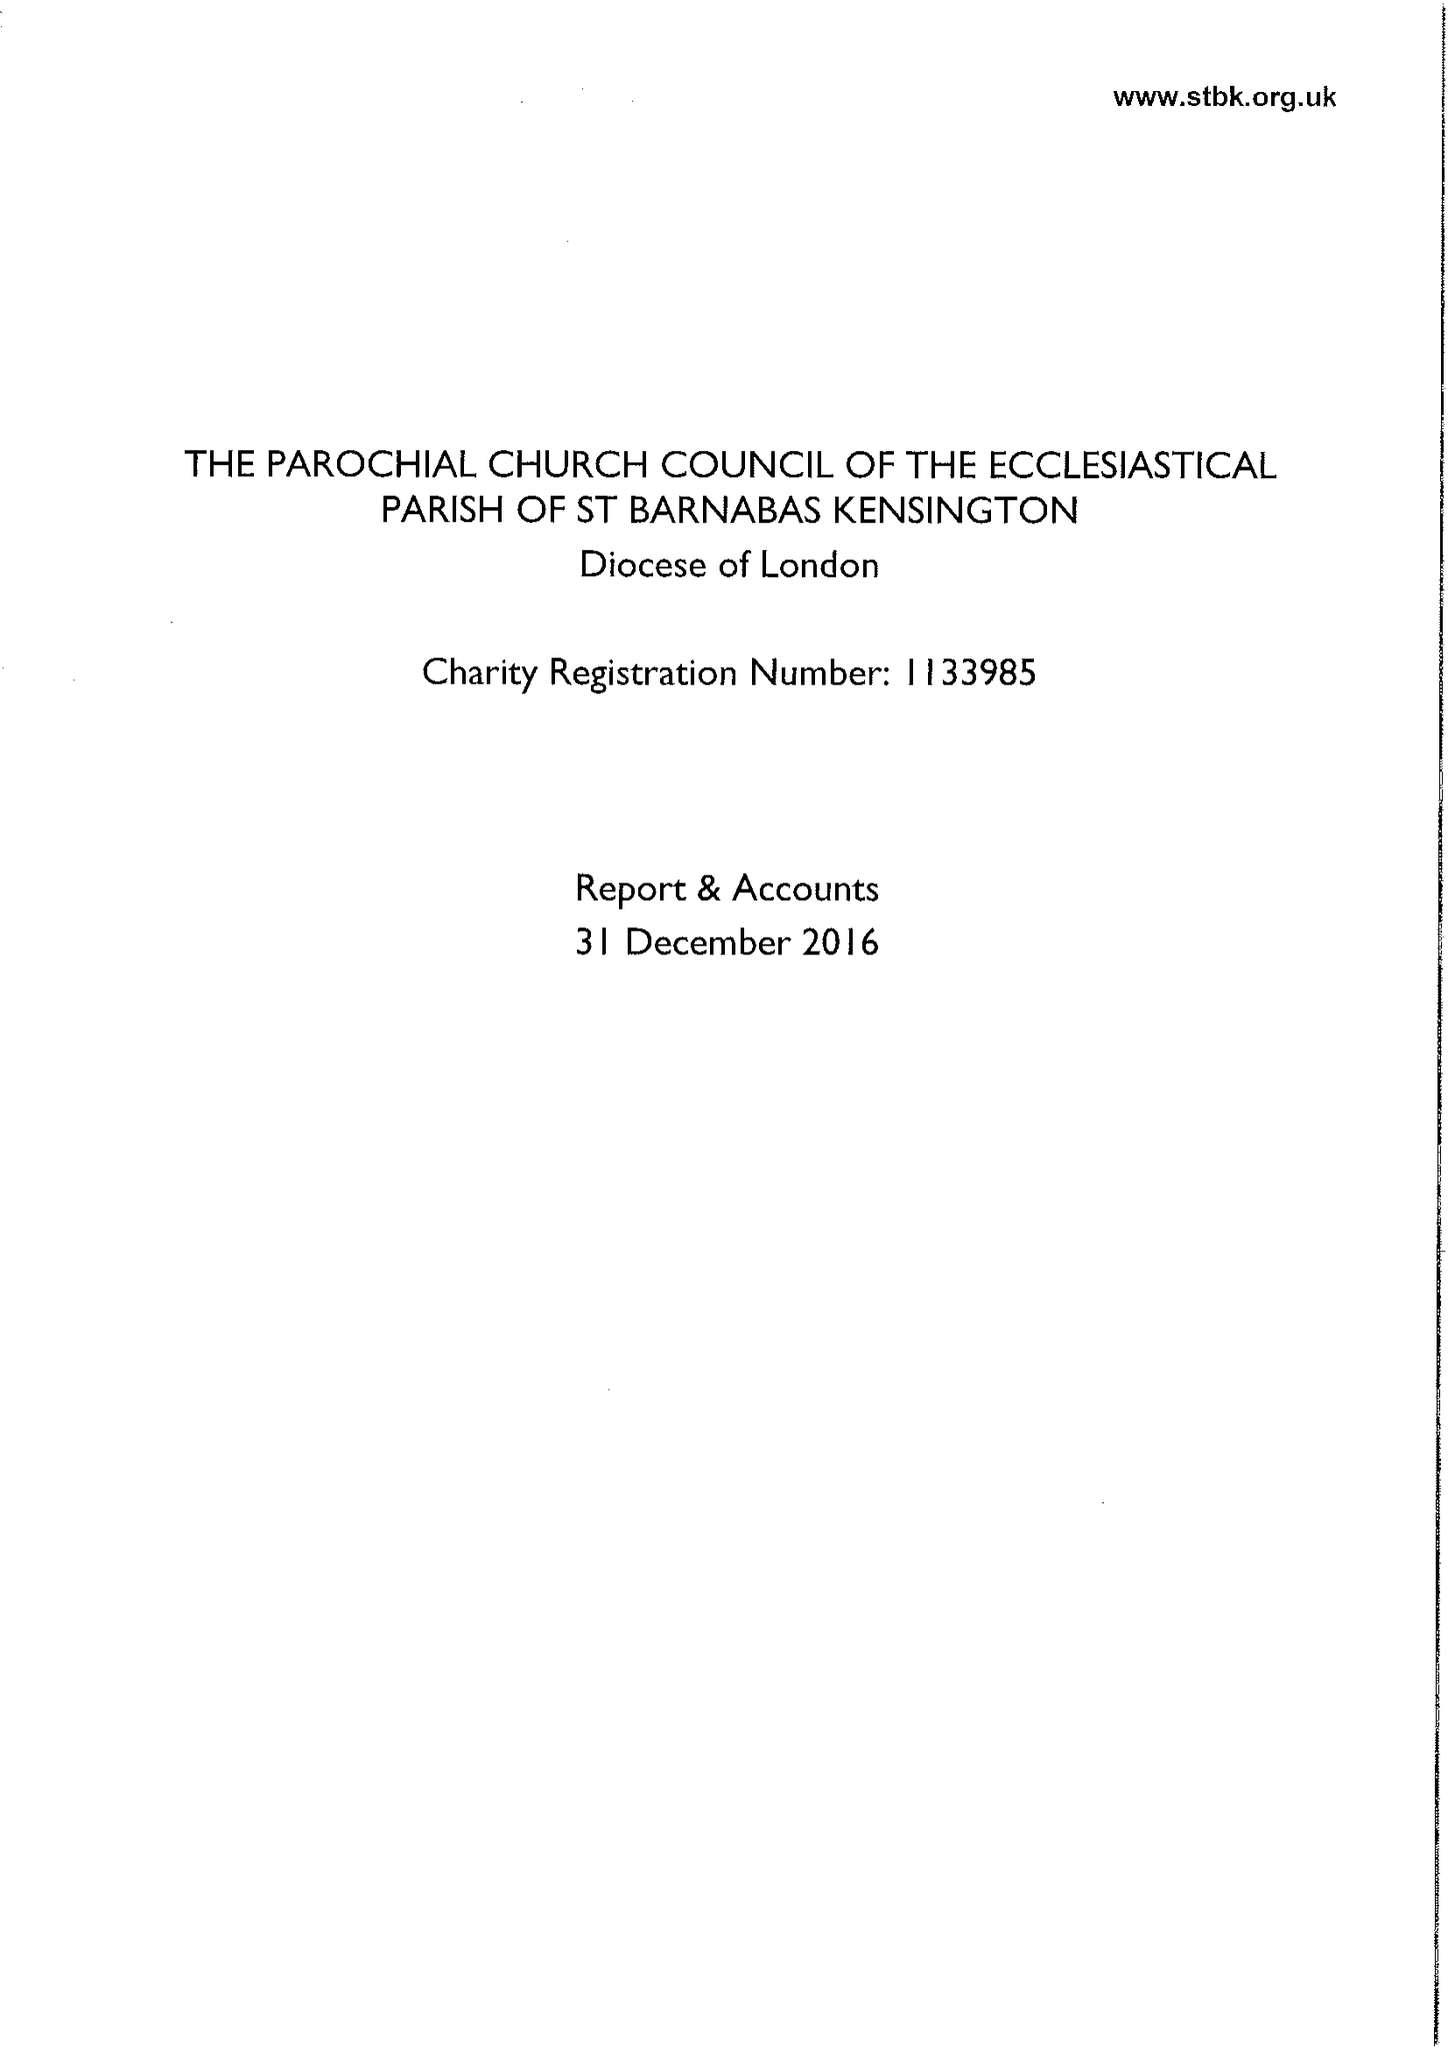What is the value for the charity_name?
Answer the question using a single word or phrase. The Parochial Church Council Of The Ecclesiastical Parish Of St Barnabas Kensington 